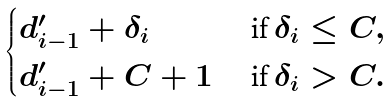<formula> <loc_0><loc_0><loc_500><loc_500>\begin{cases} d ^ { \prime } _ { i - 1 } + \delta _ { i } & \text { if } \delta _ { i } \leq C , \\ d ^ { \prime } _ { i - 1 } + C + 1 & \text { if } \delta _ { i } > C . \end{cases}</formula> 